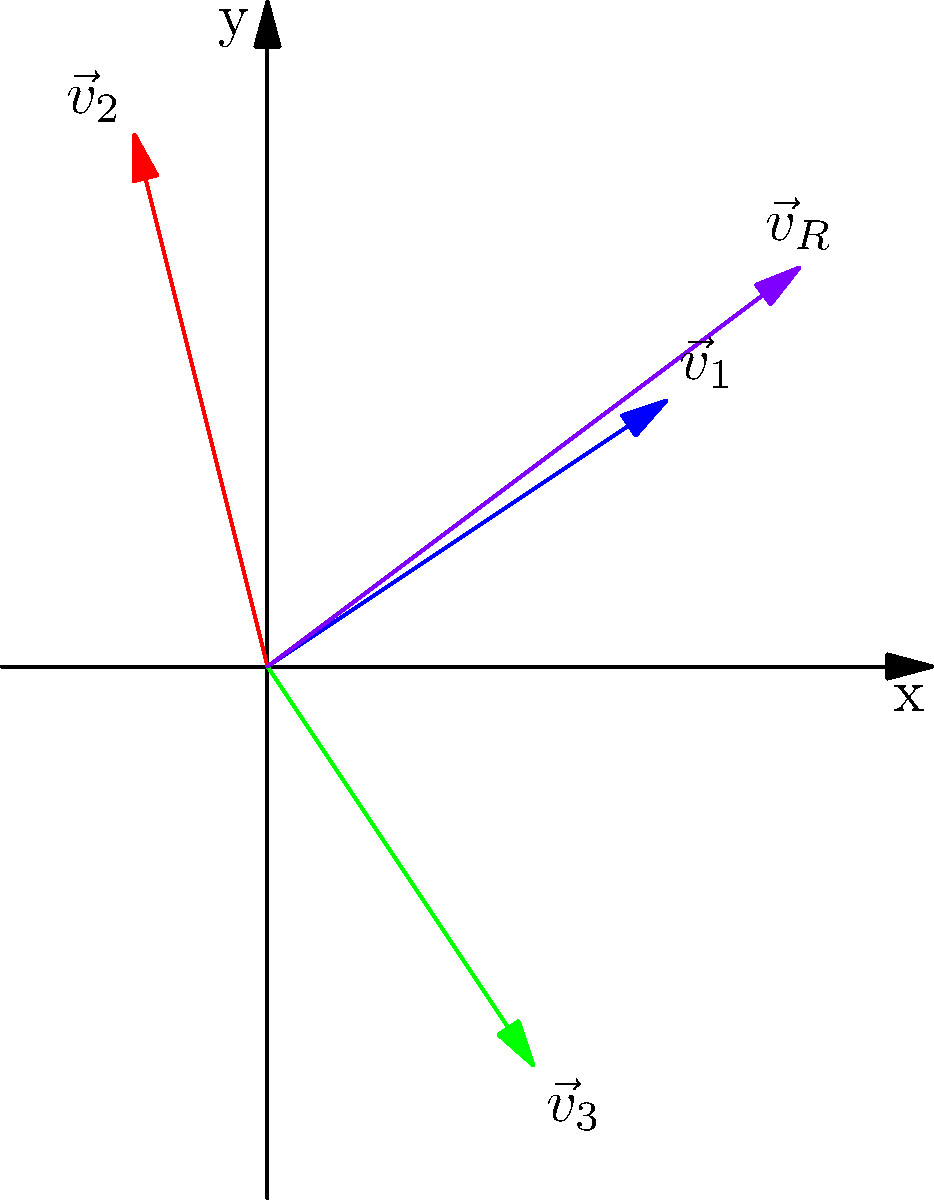In your kinetic art installation, you're working with three vector components represented by $\vec{v}_1$, $\vec{v}_2$, and $\vec{v}_3$ as shown in the diagram. To create a balanced and visually striking piece, you need to find the resultant vector $\vec{v}_R$. Calculate the magnitude of $\vec{v}_R$ to determine the overall force and direction of your installation's movement. To find the magnitude of the resultant vector $\vec{v}_R$, we'll follow these steps:

1) First, we need to add the three vectors:
   $\vec{v}_R = \vec{v}_1 + \vec{v}_2 + \vec{v}_3$

2) From the diagram, we can see:
   $\vec{v}_1 = (3,2)$
   $\vec{v}_2 = (-1,4)$
   $\vec{v}_3 = (2,-3)$

3) Adding these vectors:
   $\vec{v}_R = (3,2) + (-1,4) + (2,-3)$
   $\vec{v}_R = (3-1+2, 2+4-3)$
   $\vec{v}_R = (4,3)$

4) To find the magnitude of $\vec{v}_R$, we use the Pythagorean theorem:
   $|\vec{v}_R| = \sqrt{x^2 + y^2}$

5) Substituting our values:
   $|\vec{v}_R| = \sqrt{4^2 + 3^2}$
   $|\vec{v}_R| = \sqrt{16 + 9}$
   $|\vec{v}_R| = \sqrt{25}$
   $|\vec{v}_R| = 5$

Therefore, the magnitude of the resultant vector $\vec{v}_R$ is 5 units.
Answer: 5 units 